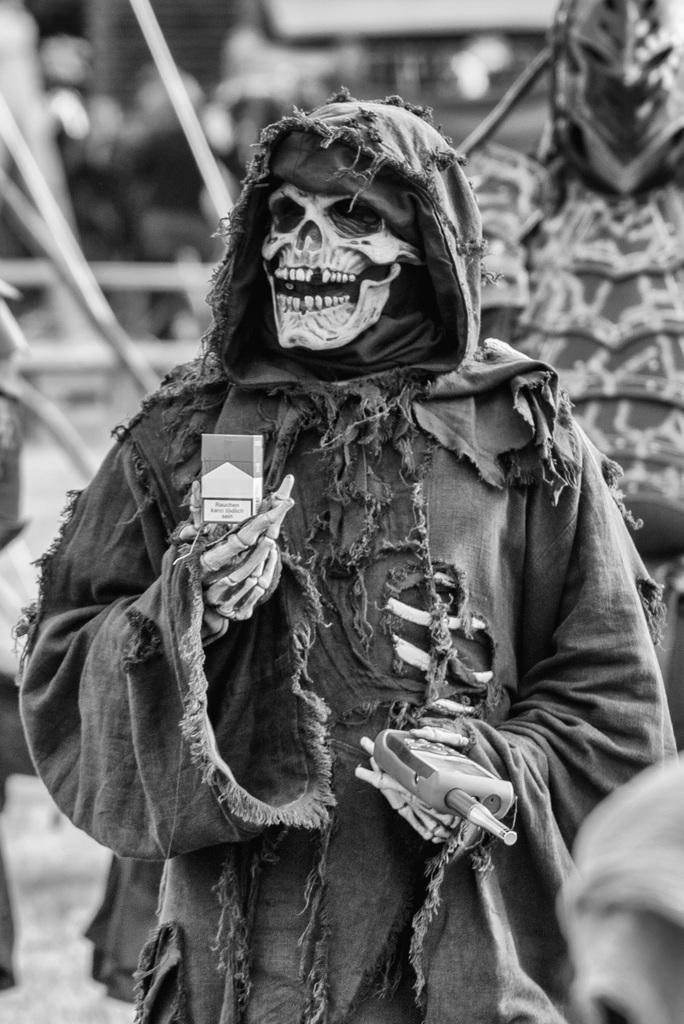What is the person in the image wearing? The person is wearing a costume. What is the person holding in their hand? The person is holding a packet and a walkie-talkie. Can you describe the background of the image? The background of the image is blurry. What type of flight can be seen in the image? There is no flight visible in the image. Is there a kitten present in the image? No, there is no kitten present in the image. 